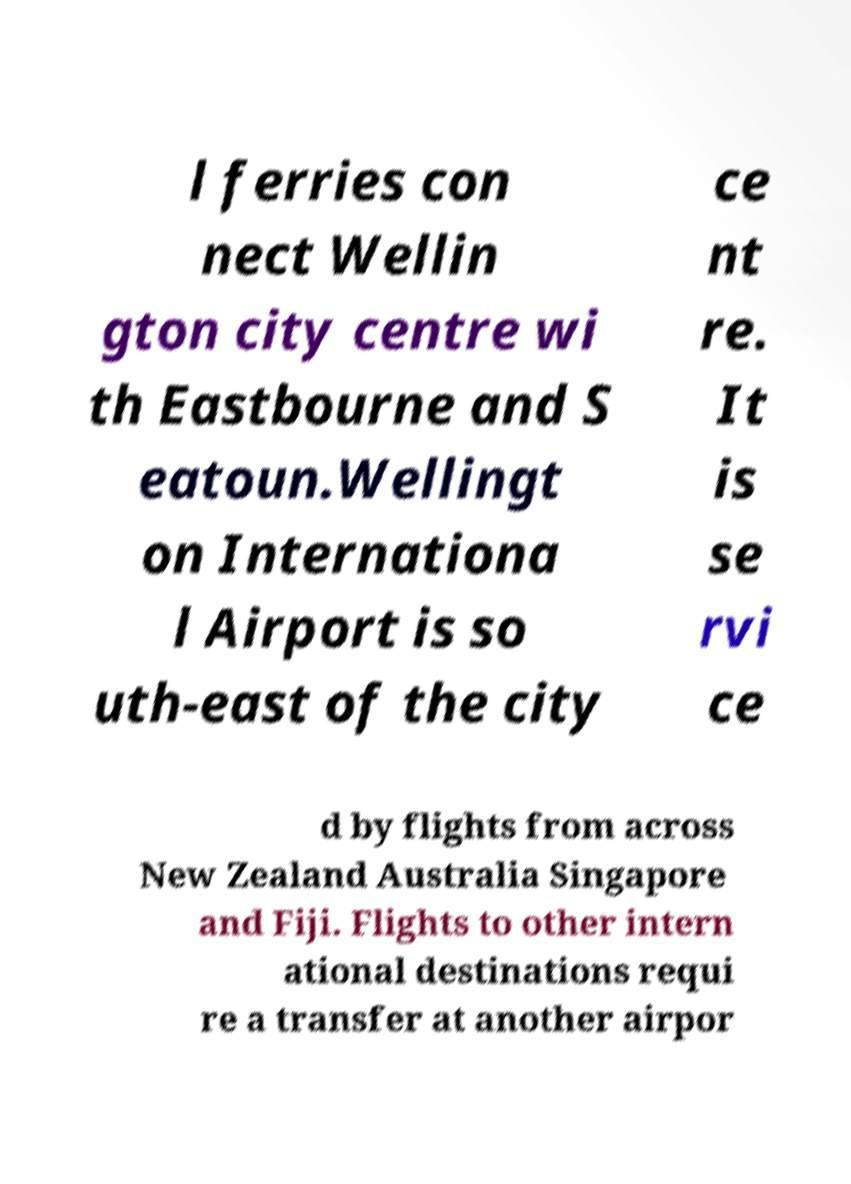Can you read and provide the text displayed in the image?This photo seems to have some interesting text. Can you extract and type it out for me? l ferries con nect Wellin gton city centre wi th Eastbourne and S eatoun.Wellingt on Internationa l Airport is so uth-east of the city ce nt re. It is se rvi ce d by flights from across New Zealand Australia Singapore and Fiji. Flights to other intern ational destinations requi re a transfer at another airpor 